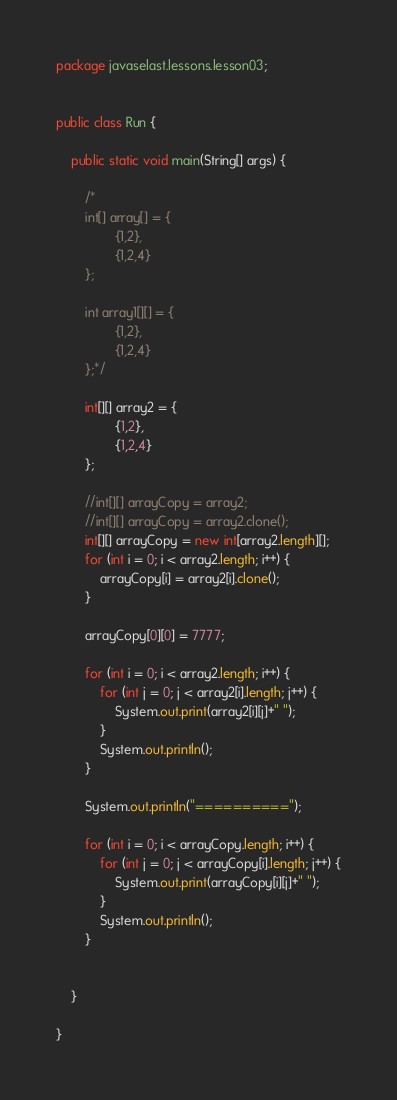Convert code to text. <code><loc_0><loc_0><loc_500><loc_500><_Java_>package javaselast.lessons.lesson03;


public class Run {

    public static void main(String[] args) {

        /*
        int[] array[] = {
                {1,2},
                {1,2,4}
        };

        int array1[][] = {
                {1,2},
                {1,2,4}
        };*/

        int[][] array2 = {
                {1,2},
                {1,2,4}
        };

        //int[][] arrayCopy = array2;
        //int[][] arrayCopy = array2.clone();
        int[][] arrayCopy = new int[array2.length][];
        for (int i = 0; i < array2.length; i++) {
            arrayCopy[i] = array2[i].clone();
        }

        arrayCopy[0][0] = 7777;

        for (int i = 0; i < array2.length; i++) {
            for (int j = 0; j < array2[i].length; j++) {
                System.out.print(array2[i][j]+" ");
            }
            System.out.println();
        }

        System.out.println("==========");

        for (int i = 0; i < arrayCopy.length; i++) {
            for (int j = 0; j < arrayCopy[i].length; j++) {
                System.out.print(arrayCopy[i][j]+" ");
            }
            System.out.println();
        }


    }

}
</code> 